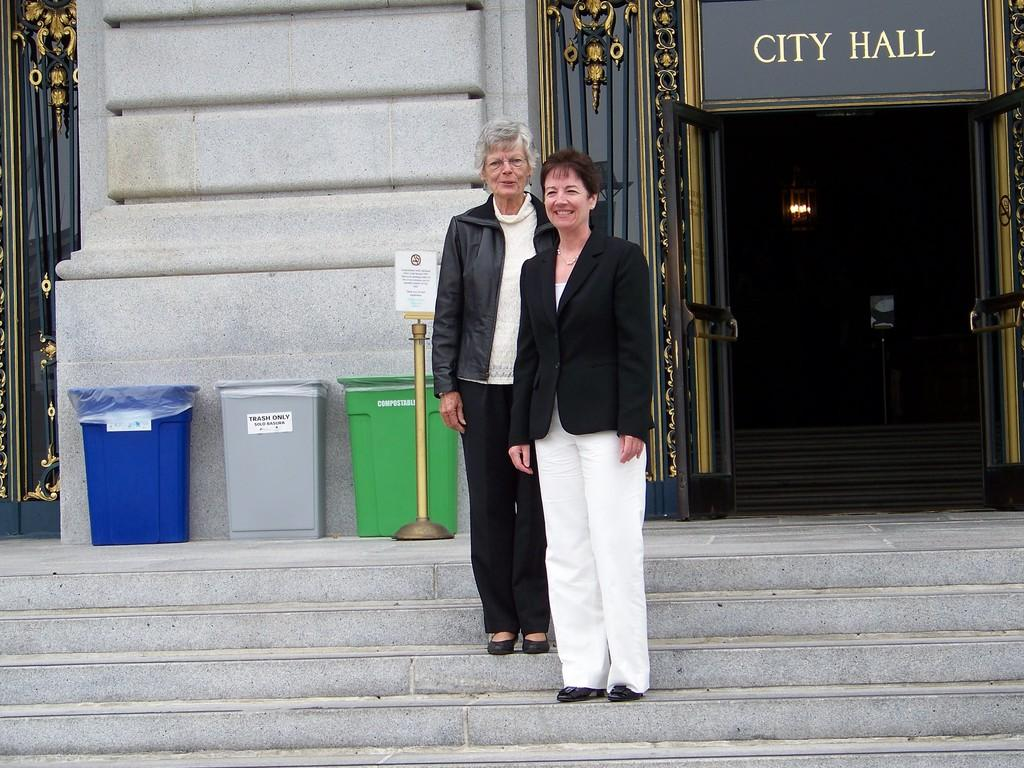Who are the main subjects in the image? There are two ladies in the center of the image. What can be seen on the right side of the image? There is a door on the right side of the image. What is located on the left side of the image? There are dustbins on the left side of the image. What type of engine can be seen in the image? There is no engine present in the image. What color is the silver pest in the image? There is no pest or silver object present in the image. 